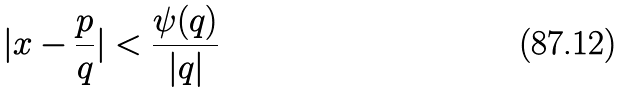Convert formula to latex. <formula><loc_0><loc_0><loc_500><loc_500>| x - \frac { p } { q } | < \frac { \psi ( q ) } { | q | }</formula> 